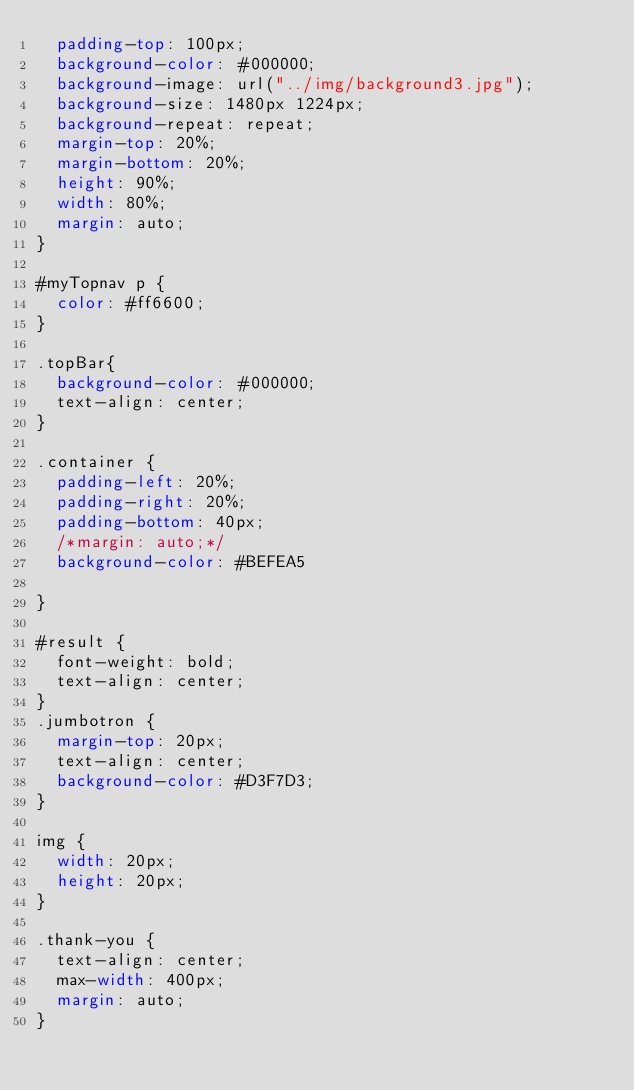<code> <loc_0><loc_0><loc_500><loc_500><_CSS_>  padding-top: 100px;
  background-color: #000000;
  background-image: url("../img/background3.jpg");
  background-size: 1480px 1224px;
  background-repeat: repeat;
  margin-top: 20%;
  margin-bottom: 20%;
  height: 90%;
  width: 80%;
  margin: auto;
}

#myTopnav p {
  color: #ff6600;
}

.topBar{
  background-color: #000000;
  text-align: center;
}

.container {
  padding-left: 20%;
  padding-right: 20%;
  padding-bottom: 40px;
  /*margin: auto;*/
  background-color: #BEFEA5

}

#result {
  font-weight: bold;
  text-align: center;
}
.jumbotron {
  margin-top: 20px;
  text-align: center;
  background-color: #D3F7D3;
}

img {
  width: 20px;
  height: 20px;
}

.thank-you {
  text-align: center;
  max-width: 400px;
  margin: auto;
}
</code> 